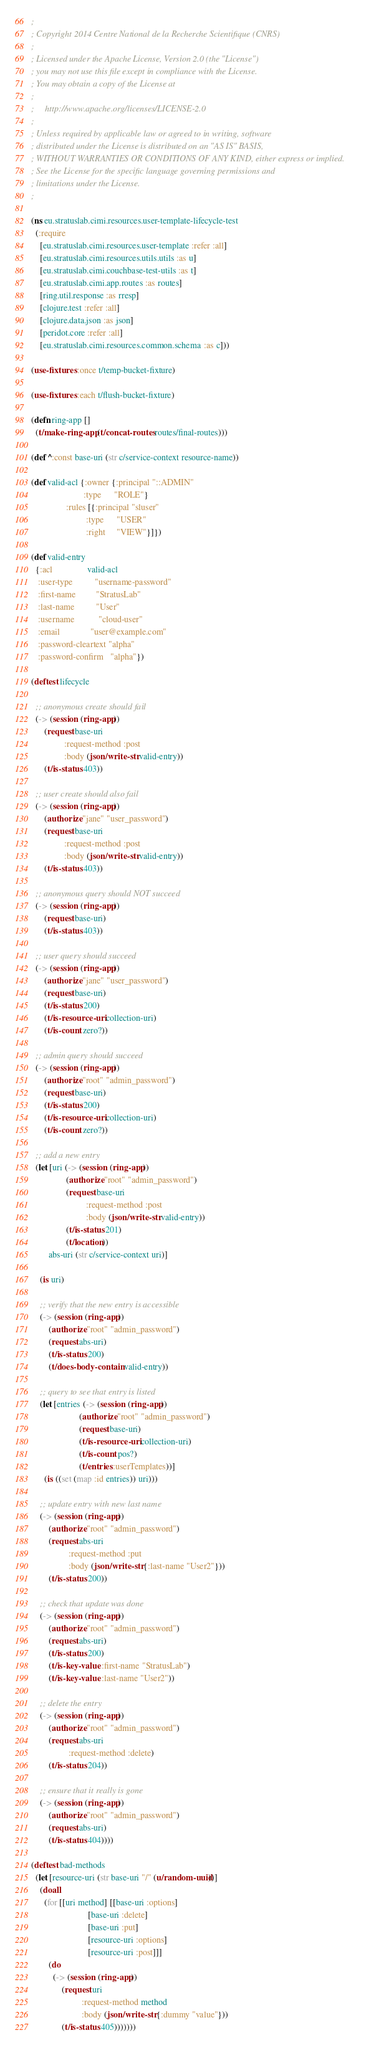<code> <loc_0><loc_0><loc_500><loc_500><_Clojure_>;
; Copyright 2014 Centre National de la Recherche Scientifique (CNRS)
;
; Licensed under the Apache License, Version 2.0 (the "License")
; you may not use this file except in compliance with the License.
; You may obtain a copy of the License at
;
;     http://www.apache.org/licenses/LICENSE-2.0
;
; Unless required by applicable law or agreed to in writing, software
; distributed under the License is distributed on an "AS IS" BASIS,
; WITHOUT WARRANTIES OR CONDITIONS OF ANY KIND, either express or implied.
; See the License for the specific language governing permissions and
; limitations under the License.
;

(ns eu.stratuslab.cimi.resources.user-template-lifecycle-test
  (:require
    [eu.stratuslab.cimi.resources.user-template :refer :all]
    [eu.stratuslab.cimi.resources.utils.utils :as u]
    [eu.stratuslab.cimi.couchbase-test-utils :as t]
    [eu.stratuslab.cimi.app.routes :as routes]
    [ring.util.response :as rresp]
    [clojure.test :refer :all]
    [clojure.data.json :as json]
    [peridot.core :refer :all]
    [eu.stratuslab.cimi.resources.common.schema :as c]))

(use-fixtures :once t/temp-bucket-fixture)

(use-fixtures :each t/flush-bucket-fixture)

(defn ring-app []
  (t/make-ring-app (t/concat-routes routes/final-routes)))

(def ^:const base-uri (str c/service-context resource-name))

(def valid-acl {:owner {:principal "::ADMIN"
                        :type      "ROLE"}
                :rules [{:principal "sluser"
                         :type      "USER"
                         :right     "VIEW"}]})

(def valid-entry
  {:acl                valid-acl
   :user-type          "username-password"
   :first-name         "StratusLab"
   :last-name          "User"
   :username           "cloud-user"
   :email              "user@example.com"
   :password-cleartext "alpha"
   :password-confirm   "alpha"})

(deftest lifecycle

  ;; anonymous create should fail
  (-> (session (ring-app))
      (request base-uri
               :request-method :post
               :body (json/write-str valid-entry))
      (t/is-status 403))

  ;; user create should also fail
  (-> (session (ring-app))
      (authorize "jane" "user_password")
      (request base-uri
               :request-method :post
               :body (json/write-str valid-entry))
      (t/is-status 403))

  ;; anonymous query should NOT succeed
  (-> (session (ring-app))
      (request base-uri)
      (t/is-status 403))

  ;; user query should succeed
  (-> (session (ring-app))
      (authorize "jane" "user_password")
      (request base-uri)
      (t/is-status 200)
      (t/is-resource-uri collection-uri)
      (t/is-count zero?))

  ;; admin query should succeed
  (-> (session (ring-app))
      (authorize "root" "admin_password")
      (request base-uri)
      (t/is-status 200)
      (t/is-resource-uri collection-uri)
      (t/is-count zero?))

  ;; add a new entry
  (let [uri (-> (session (ring-app))
                (authorize "root" "admin_password")
                (request base-uri
                         :request-method :post
                         :body (json/write-str valid-entry))
                (t/is-status 201)
                (t/location))
        abs-uri (str c/service-context uri)]

    (is uri)

    ;; verify that the new entry is accessible
    (-> (session (ring-app))
        (authorize "root" "admin_password")
        (request abs-uri)
        (t/is-status 200)
        (t/does-body-contain valid-entry))

    ;; query to see that entry is listed
    (let [entries (-> (session (ring-app))
                      (authorize "root" "admin_password")
                      (request base-uri)
                      (t/is-resource-uri collection-uri)
                      (t/is-count pos?)
                      (t/entries :userTemplates))]
      (is ((set (map :id entries)) uri)))

    ;; update entry with new last name
    (-> (session (ring-app))
        (authorize "root" "admin_password")
        (request abs-uri
                 :request-method :put
                 :body (json/write-str {:last-name "User2"}))
        (t/is-status 200))

    ;; check that update was done
    (-> (session (ring-app))
        (authorize "root" "admin_password")
        (request abs-uri)
        (t/is-status 200)
        (t/is-key-value :first-name "StratusLab")
        (t/is-key-value :last-name "User2"))

    ;; delete the entry
    (-> (session (ring-app))
        (authorize "root" "admin_password")
        (request abs-uri
                 :request-method :delete)
        (t/is-status 204))

    ;; ensure that it really is gone
    (-> (session (ring-app))
        (authorize "root" "admin_password")
        (request abs-uri)
        (t/is-status 404))))

(deftest bad-methods
  (let [resource-uri (str base-uri "/" (u/random-uuid))]
    (doall
      (for [[uri method] [[base-uri :options]
                          [base-uri :delete]
                          [base-uri :put]
                          [resource-uri :options]
                          [resource-uri :post]]]
        (do
          (-> (session (ring-app))
              (request uri
                       :request-method method
                       :body (json/write-str {:dummy "value"}))
              (t/is-status 405)))))))
</code> 